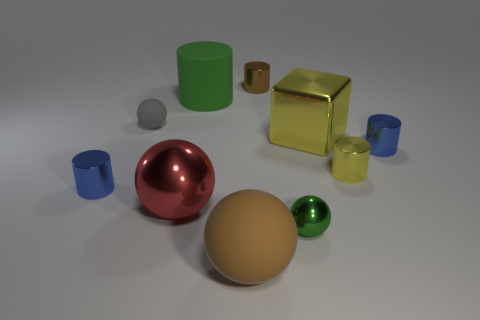There is a green cylinder to the right of the big red ball; what is its size?
Your answer should be compact. Large. The large red shiny object has what shape?
Provide a succinct answer. Sphere. There is a blue metal thing that is to the left of the green metallic thing; is it the same size as the rubber sphere that is behind the green shiny sphere?
Give a very brief answer. Yes. There is a green thing behind the tiny metallic thing in front of the tiny metallic object that is on the left side of the green cylinder; what size is it?
Give a very brief answer. Large. The brown object that is behind the small blue shiny thing in front of the blue object that is behind the small yellow thing is what shape?
Your answer should be compact. Cylinder. What shape is the big yellow object that is in front of the large green object?
Make the answer very short. Cube. Are the gray object and the cylinder that is in front of the tiny yellow cylinder made of the same material?
Ensure brevity in your answer.  No. How many other objects are the same shape as the red metallic thing?
Make the answer very short. 3. Do the metal cube and the tiny sphere that is on the right side of the tiny brown shiny object have the same color?
Offer a very short reply. No. Are there any other things that are made of the same material as the gray ball?
Offer a terse response. Yes. 